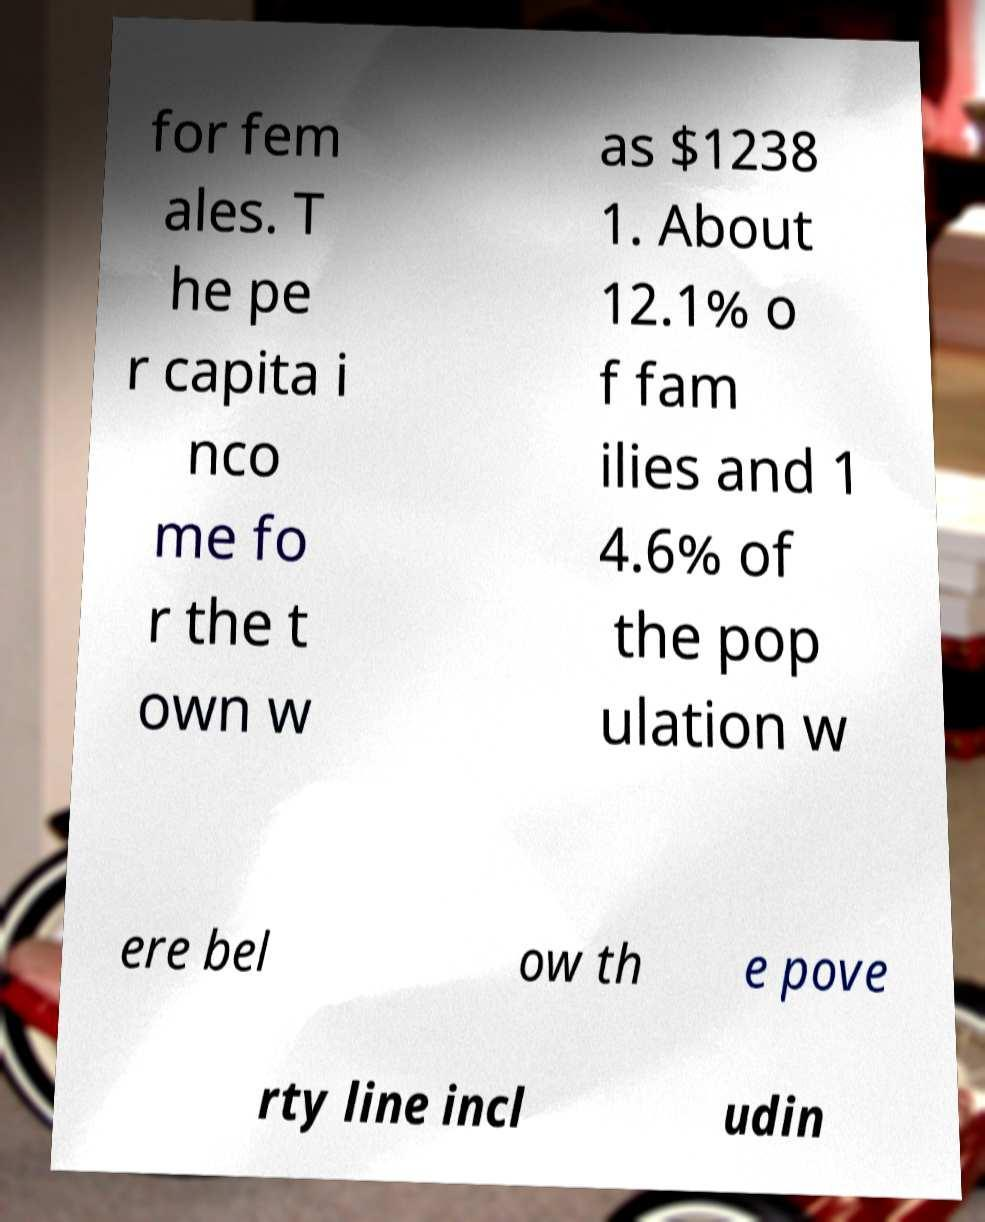I need the written content from this picture converted into text. Can you do that? for fem ales. T he pe r capita i nco me fo r the t own w as $1238 1. About 12.1% o f fam ilies and 1 4.6% of the pop ulation w ere bel ow th e pove rty line incl udin 